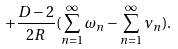Convert formula to latex. <formula><loc_0><loc_0><loc_500><loc_500>+ \frac { D - 2 } { 2 R } ( \sum _ { n = 1 } ^ { \infty } \omega _ { n } - \sum _ { n = 1 } ^ { \infty } \nu _ { n } ) .</formula> 